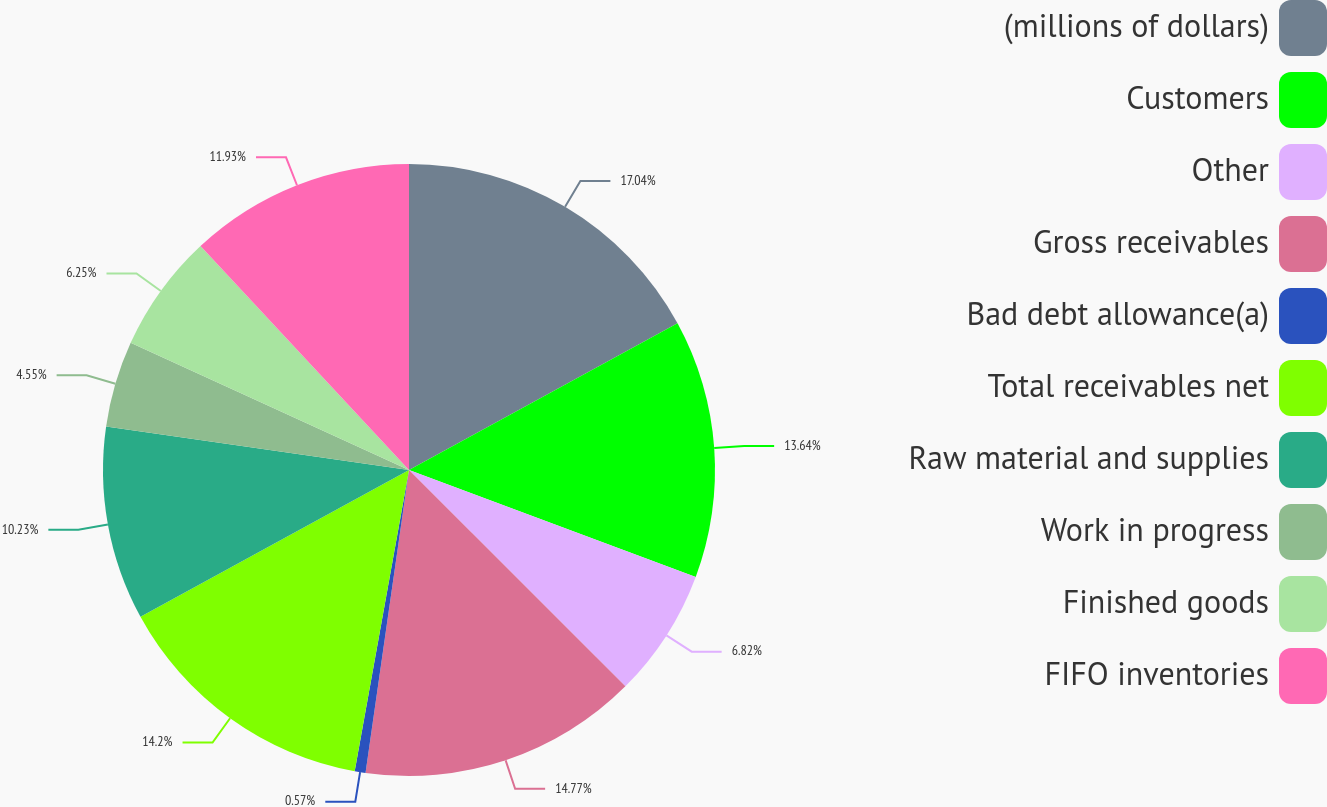Convert chart. <chart><loc_0><loc_0><loc_500><loc_500><pie_chart><fcel>(millions of dollars)<fcel>Customers<fcel>Other<fcel>Gross receivables<fcel>Bad debt allowance(a)<fcel>Total receivables net<fcel>Raw material and supplies<fcel>Work in progress<fcel>Finished goods<fcel>FIFO inventories<nl><fcel>17.04%<fcel>13.64%<fcel>6.82%<fcel>14.77%<fcel>0.57%<fcel>14.2%<fcel>10.23%<fcel>4.55%<fcel>6.25%<fcel>11.93%<nl></chart> 